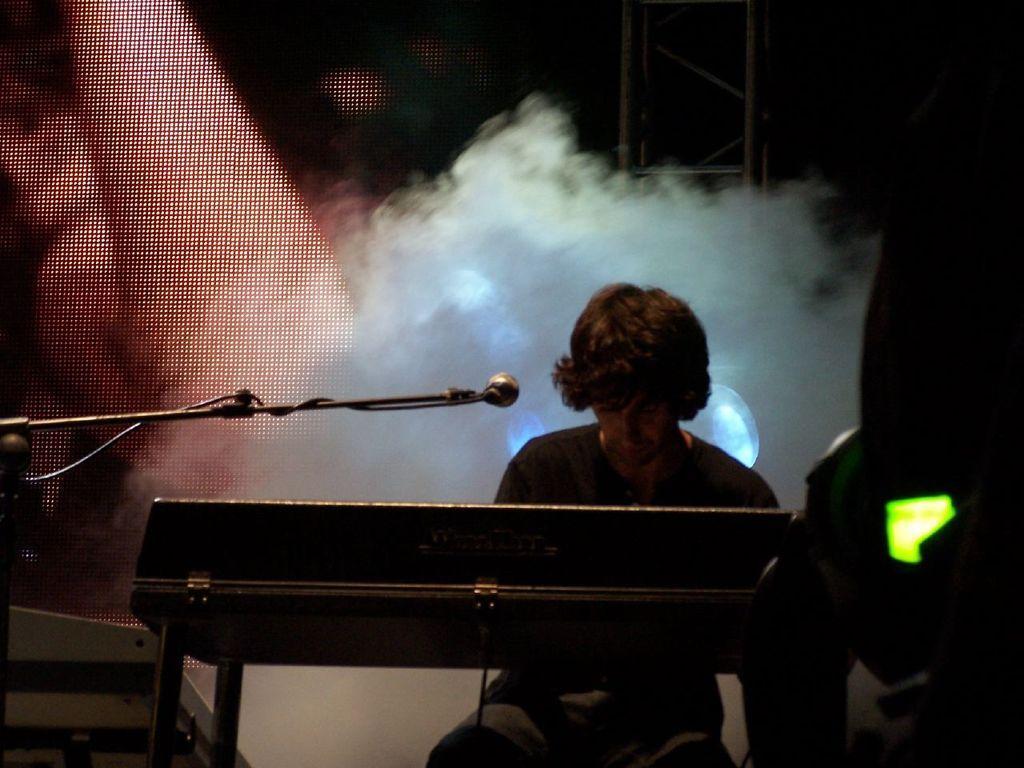In one or two sentences, can you explain what this image depicts? This image might be clicked in a musical concert. There is a smoke in the middle. There is a mic placed in the middle. There is a person sitting, there is a keyboard in front of him, he is playing keyboard. There are lights back side. 